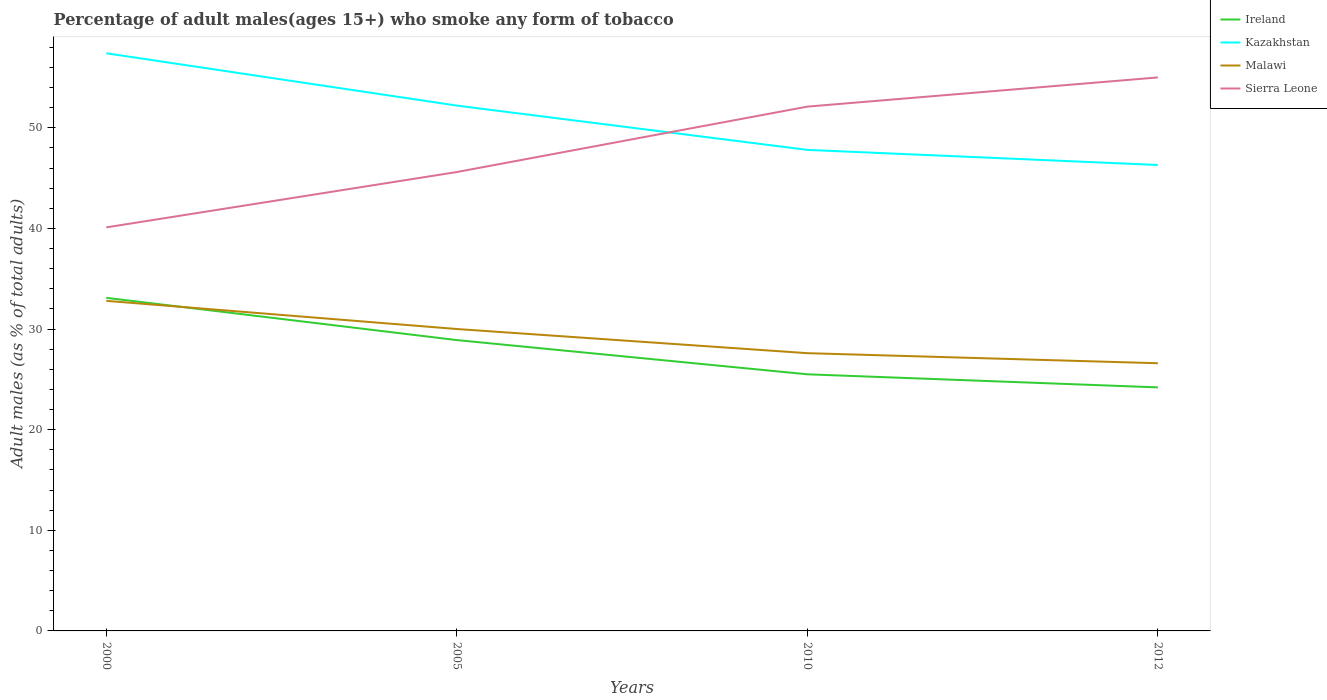How many different coloured lines are there?
Your answer should be compact. 4. Does the line corresponding to Ireland intersect with the line corresponding to Kazakhstan?
Provide a succinct answer. No. Is the number of lines equal to the number of legend labels?
Make the answer very short. Yes. Across all years, what is the maximum percentage of adult males who smoke in Kazakhstan?
Give a very brief answer. 46.3. In which year was the percentage of adult males who smoke in Ireland maximum?
Your answer should be compact. 2012. What is the total percentage of adult males who smoke in Ireland in the graph?
Ensure brevity in your answer.  4.2. What is the difference between the highest and the second highest percentage of adult males who smoke in Malawi?
Offer a terse response. 6.2. What is the difference between the highest and the lowest percentage of adult males who smoke in Kazakhstan?
Your response must be concise. 2. Is the percentage of adult males who smoke in Sierra Leone strictly greater than the percentage of adult males who smoke in Malawi over the years?
Offer a terse response. No. How many lines are there?
Give a very brief answer. 4. How many years are there in the graph?
Give a very brief answer. 4. What is the difference between two consecutive major ticks on the Y-axis?
Make the answer very short. 10. Are the values on the major ticks of Y-axis written in scientific E-notation?
Keep it short and to the point. No. Does the graph contain any zero values?
Ensure brevity in your answer.  No. Does the graph contain grids?
Offer a very short reply. No. Where does the legend appear in the graph?
Your answer should be very brief. Top right. What is the title of the graph?
Ensure brevity in your answer.  Percentage of adult males(ages 15+) who smoke any form of tobacco. What is the label or title of the X-axis?
Keep it short and to the point. Years. What is the label or title of the Y-axis?
Make the answer very short. Adult males (as % of total adults). What is the Adult males (as % of total adults) in Ireland in 2000?
Your answer should be compact. 33.1. What is the Adult males (as % of total adults) of Kazakhstan in 2000?
Provide a succinct answer. 57.4. What is the Adult males (as % of total adults) of Malawi in 2000?
Your answer should be very brief. 32.8. What is the Adult males (as % of total adults) of Sierra Leone in 2000?
Keep it short and to the point. 40.1. What is the Adult males (as % of total adults) in Ireland in 2005?
Your answer should be very brief. 28.9. What is the Adult males (as % of total adults) in Kazakhstan in 2005?
Offer a terse response. 52.2. What is the Adult males (as % of total adults) of Malawi in 2005?
Offer a terse response. 30. What is the Adult males (as % of total adults) in Sierra Leone in 2005?
Your response must be concise. 45.6. What is the Adult males (as % of total adults) in Ireland in 2010?
Offer a terse response. 25.5. What is the Adult males (as % of total adults) in Kazakhstan in 2010?
Ensure brevity in your answer.  47.8. What is the Adult males (as % of total adults) in Malawi in 2010?
Ensure brevity in your answer.  27.6. What is the Adult males (as % of total adults) of Sierra Leone in 2010?
Give a very brief answer. 52.1. What is the Adult males (as % of total adults) in Ireland in 2012?
Ensure brevity in your answer.  24.2. What is the Adult males (as % of total adults) of Kazakhstan in 2012?
Offer a terse response. 46.3. What is the Adult males (as % of total adults) in Malawi in 2012?
Your response must be concise. 26.6. What is the Adult males (as % of total adults) of Sierra Leone in 2012?
Offer a very short reply. 55. Across all years, what is the maximum Adult males (as % of total adults) in Ireland?
Provide a short and direct response. 33.1. Across all years, what is the maximum Adult males (as % of total adults) of Kazakhstan?
Offer a terse response. 57.4. Across all years, what is the maximum Adult males (as % of total adults) of Malawi?
Your response must be concise. 32.8. Across all years, what is the maximum Adult males (as % of total adults) in Sierra Leone?
Give a very brief answer. 55. Across all years, what is the minimum Adult males (as % of total adults) of Ireland?
Offer a terse response. 24.2. Across all years, what is the minimum Adult males (as % of total adults) in Kazakhstan?
Your answer should be compact. 46.3. Across all years, what is the minimum Adult males (as % of total adults) in Malawi?
Ensure brevity in your answer.  26.6. Across all years, what is the minimum Adult males (as % of total adults) of Sierra Leone?
Make the answer very short. 40.1. What is the total Adult males (as % of total adults) in Ireland in the graph?
Provide a short and direct response. 111.7. What is the total Adult males (as % of total adults) of Kazakhstan in the graph?
Provide a succinct answer. 203.7. What is the total Adult males (as % of total adults) of Malawi in the graph?
Make the answer very short. 117. What is the total Adult males (as % of total adults) in Sierra Leone in the graph?
Ensure brevity in your answer.  192.8. What is the difference between the Adult males (as % of total adults) of Malawi in 2000 and that in 2005?
Give a very brief answer. 2.8. What is the difference between the Adult males (as % of total adults) of Ireland in 2000 and that in 2010?
Provide a short and direct response. 7.6. What is the difference between the Adult males (as % of total adults) in Malawi in 2000 and that in 2010?
Your response must be concise. 5.2. What is the difference between the Adult males (as % of total adults) in Malawi in 2000 and that in 2012?
Your answer should be very brief. 6.2. What is the difference between the Adult males (as % of total adults) of Sierra Leone in 2000 and that in 2012?
Offer a very short reply. -14.9. What is the difference between the Adult males (as % of total adults) in Ireland in 2005 and that in 2012?
Keep it short and to the point. 4.7. What is the difference between the Adult males (as % of total adults) in Kazakhstan in 2005 and that in 2012?
Your answer should be compact. 5.9. What is the difference between the Adult males (as % of total adults) in Malawi in 2005 and that in 2012?
Provide a succinct answer. 3.4. What is the difference between the Adult males (as % of total adults) of Ireland in 2010 and that in 2012?
Your answer should be compact. 1.3. What is the difference between the Adult males (as % of total adults) in Kazakhstan in 2010 and that in 2012?
Give a very brief answer. 1.5. What is the difference between the Adult males (as % of total adults) of Sierra Leone in 2010 and that in 2012?
Your response must be concise. -2.9. What is the difference between the Adult males (as % of total adults) in Ireland in 2000 and the Adult males (as % of total adults) in Kazakhstan in 2005?
Give a very brief answer. -19.1. What is the difference between the Adult males (as % of total adults) of Ireland in 2000 and the Adult males (as % of total adults) of Sierra Leone in 2005?
Provide a short and direct response. -12.5. What is the difference between the Adult males (as % of total adults) in Kazakhstan in 2000 and the Adult males (as % of total adults) in Malawi in 2005?
Provide a succinct answer. 27.4. What is the difference between the Adult males (as % of total adults) of Ireland in 2000 and the Adult males (as % of total adults) of Kazakhstan in 2010?
Make the answer very short. -14.7. What is the difference between the Adult males (as % of total adults) in Ireland in 2000 and the Adult males (as % of total adults) in Malawi in 2010?
Offer a terse response. 5.5. What is the difference between the Adult males (as % of total adults) in Kazakhstan in 2000 and the Adult males (as % of total adults) in Malawi in 2010?
Offer a terse response. 29.8. What is the difference between the Adult males (as % of total adults) of Malawi in 2000 and the Adult males (as % of total adults) of Sierra Leone in 2010?
Your answer should be compact. -19.3. What is the difference between the Adult males (as % of total adults) in Ireland in 2000 and the Adult males (as % of total adults) in Sierra Leone in 2012?
Keep it short and to the point. -21.9. What is the difference between the Adult males (as % of total adults) in Kazakhstan in 2000 and the Adult males (as % of total adults) in Malawi in 2012?
Offer a terse response. 30.8. What is the difference between the Adult males (as % of total adults) in Malawi in 2000 and the Adult males (as % of total adults) in Sierra Leone in 2012?
Make the answer very short. -22.2. What is the difference between the Adult males (as % of total adults) in Ireland in 2005 and the Adult males (as % of total adults) in Kazakhstan in 2010?
Ensure brevity in your answer.  -18.9. What is the difference between the Adult males (as % of total adults) in Ireland in 2005 and the Adult males (as % of total adults) in Malawi in 2010?
Offer a very short reply. 1.3. What is the difference between the Adult males (as % of total adults) of Ireland in 2005 and the Adult males (as % of total adults) of Sierra Leone in 2010?
Make the answer very short. -23.2. What is the difference between the Adult males (as % of total adults) of Kazakhstan in 2005 and the Adult males (as % of total adults) of Malawi in 2010?
Offer a very short reply. 24.6. What is the difference between the Adult males (as % of total adults) in Malawi in 2005 and the Adult males (as % of total adults) in Sierra Leone in 2010?
Make the answer very short. -22.1. What is the difference between the Adult males (as % of total adults) in Ireland in 2005 and the Adult males (as % of total adults) in Kazakhstan in 2012?
Your response must be concise. -17.4. What is the difference between the Adult males (as % of total adults) in Ireland in 2005 and the Adult males (as % of total adults) in Malawi in 2012?
Your answer should be very brief. 2.3. What is the difference between the Adult males (as % of total adults) in Ireland in 2005 and the Adult males (as % of total adults) in Sierra Leone in 2012?
Ensure brevity in your answer.  -26.1. What is the difference between the Adult males (as % of total adults) in Kazakhstan in 2005 and the Adult males (as % of total adults) in Malawi in 2012?
Keep it short and to the point. 25.6. What is the difference between the Adult males (as % of total adults) in Ireland in 2010 and the Adult males (as % of total adults) in Kazakhstan in 2012?
Ensure brevity in your answer.  -20.8. What is the difference between the Adult males (as % of total adults) in Ireland in 2010 and the Adult males (as % of total adults) in Sierra Leone in 2012?
Offer a very short reply. -29.5. What is the difference between the Adult males (as % of total adults) in Kazakhstan in 2010 and the Adult males (as % of total adults) in Malawi in 2012?
Ensure brevity in your answer.  21.2. What is the difference between the Adult males (as % of total adults) in Malawi in 2010 and the Adult males (as % of total adults) in Sierra Leone in 2012?
Your answer should be very brief. -27.4. What is the average Adult males (as % of total adults) in Ireland per year?
Make the answer very short. 27.93. What is the average Adult males (as % of total adults) in Kazakhstan per year?
Make the answer very short. 50.92. What is the average Adult males (as % of total adults) of Malawi per year?
Your answer should be very brief. 29.25. What is the average Adult males (as % of total adults) of Sierra Leone per year?
Ensure brevity in your answer.  48.2. In the year 2000, what is the difference between the Adult males (as % of total adults) of Ireland and Adult males (as % of total adults) of Kazakhstan?
Your answer should be compact. -24.3. In the year 2000, what is the difference between the Adult males (as % of total adults) of Kazakhstan and Adult males (as % of total adults) of Malawi?
Offer a terse response. 24.6. In the year 2005, what is the difference between the Adult males (as % of total adults) in Ireland and Adult males (as % of total adults) in Kazakhstan?
Make the answer very short. -23.3. In the year 2005, what is the difference between the Adult males (as % of total adults) of Ireland and Adult males (as % of total adults) of Malawi?
Offer a terse response. -1.1. In the year 2005, what is the difference between the Adult males (as % of total adults) of Ireland and Adult males (as % of total adults) of Sierra Leone?
Make the answer very short. -16.7. In the year 2005, what is the difference between the Adult males (as % of total adults) of Kazakhstan and Adult males (as % of total adults) of Sierra Leone?
Give a very brief answer. 6.6. In the year 2005, what is the difference between the Adult males (as % of total adults) of Malawi and Adult males (as % of total adults) of Sierra Leone?
Offer a terse response. -15.6. In the year 2010, what is the difference between the Adult males (as % of total adults) of Ireland and Adult males (as % of total adults) of Kazakhstan?
Provide a short and direct response. -22.3. In the year 2010, what is the difference between the Adult males (as % of total adults) in Ireland and Adult males (as % of total adults) in Malawi?
Keep it short and to the point. -2.1. In the year 2010, what is the difference between the Adult males (as % of total adults) of Ireland and Adult males (as % of total adults) of Sierra Leone?
Keep it short and to the point. -26.6. In the year 2010, what is the difference between the Adult males (as % of total adults) of Kazakhstan and Adult males (as % of total adults) of Malawi?
Your answer should be compact. 20.2. In the year 2010, what is the difference between the Adult males (as % of total adults) of Kazakhstan and Adult males (as % of total adults) of Sierra Leone?
Make the answer very short. -4.3. In the year 2010, what is the difference between the Adult males (as % of total adults) of Malawi and Adult males (as % of total adults) of Sierra Leone?
Make the answer very short. -24.5. In the year 2012, what is the difference between the Adult males (as % of total adults) of Ireland and Adult males (as % of total adults) of Kazakhstan?
Ensure brevity in your answer.  -22.1. In the year 2012, what is the difference between the Adult males (as % of total adults) of Ireland and Adult males (as % of total adults) of Sierra Leone?
Keep it short and to the point. -30.8. In the year 2012, what is the difference between the Adult males (as % of total adults) in Malawi and Adult males (as % of total adults) in Sierra Leone?
Give a very brief answer. -28.4. What is the ratio of the Adult males (as % of total adults) in Ireland in 2000 to that in 2005?
Your response must be concise. 1.15. What is the ratio of the Adult males (as % of total adults) of Kazakhstan in 2000 to that in 2005?
Provide a succinct answer. 1.1. What is the ratio of the Adult males (as % of total adults) of Malawi in 2000 to that in 2005?
Offer a terse response. 1.09. What is the ratio of the Adult males (as % of total adults) of Sierra Leone in 2000 to that in 2005?
Provide a short and direct response. 0.88. What is the ratio of the Adult males (as % of total adults) in Ireland in 2000 to that in 2010?
Ensure brevity in your answer.  1.3. What is the ratio of the Adult males (as % of total adults) of Kazakhstan in 2000 to that in 2010?
Provide a short and direct response. 1.2. What is the ratio of the Adult males (as % of total adults) of Malawi in 2000 to that in 2010?
Provide a short and direct response. 1.19. What is the ratio of the Adult males (as % of total adults) of Sierra Leone in 2000 to that in 2010?
Your answer should be compact. 0.77. What is the ratio of the Adult males (as % of total adults) in Ireland in 2000 to that in 2012?
Keep it short and to the point. 1.37. What is the ratio of the Adult males (as % of total adults) in Kazakhstan in 2000 to that in 2012?
Your answer should be very brief. 1.24. What is the ratio of the Adult males (as % of total adults) in Malawi in 2000 to that in 2012?
Keep it short and to the point. 1.23. What is the ratio of the Adult males (as % of total adults) in Sierra Leone in 2000 to that in 2012?
Provide a succinct answer. 0.73. What is the ratio of the Adult males (as % of total adults) in Ireland in 2005 to that in 2010?
Give a very brief answer. 1.13. What is the ratio of the Adult males (as % of total adults) in Kazakhstan in 2005 to that in 2010?
Offer a terse response. 1.09. What is the ratio of the Adult males (as % of total adults) of Malawi in 2005 to that in 2010?
Make the answer very short. 1.09. What is the ratio of the Adult males (as % of total adults) of Sierra Leone in 2005 to that in 2010?
Your answer should be very brief. 0.88. What is the ratio of the Adult males (as % of total adults) of Ireland in 2005 to that in 2012?
Your answer should be compact. 1.19. What is the ratio of the Adult males (as % of total adults) in Kazakhstan in 2005 to that in 2012?
Ensure brevity in your answer.  1.13. What is the ratio of the Adult males (as % of total adults) in Malawi in 2005 to that in 2012?
Ensure brevity in your answer.  1.13. What is the ratio of the Adult males (as % of total adults) of Sierra Leone in 2005 to that in 2012?
Ensure brevity in your answer.  0.83. What is the ratio of the Adult males (as % of total adults) of Ireland in 2010 to that in 2012?
Give a very brief answer. 1.05. What is the ratio of the Adult males (as % of total adults) in Kazakhstan in 2010 to that in 2012?
Provide a short and direct response. 1.03. What is the ratio of the Adult males (as % of total adults) in Malawi in 2010 to that in 2012?
Offer a very short reply. 1.04. What is the ratio of the Adult males (as % of total adults) of Sierra Leone in 2010 to that in 2012?
Provide a succinct answer. 0.95. What is the difference between the highest and the second highest Adult males (as % of total adults) in Ireland?
Make the answer very short. 4.2. What is the difference between the highest and the lowest Adult males (as % of total adults) in Ireland?
Keep it short and to the point. 8.9. What is the difference between the highest and the lowest Adult males (as % of total adults) in Malawi?
Give a very brief answer. 6.2. What is the difference between the highest and the lowest Adult males (as % of total adults) in Sierra Leone?
Offer a terse response. 14.9. 